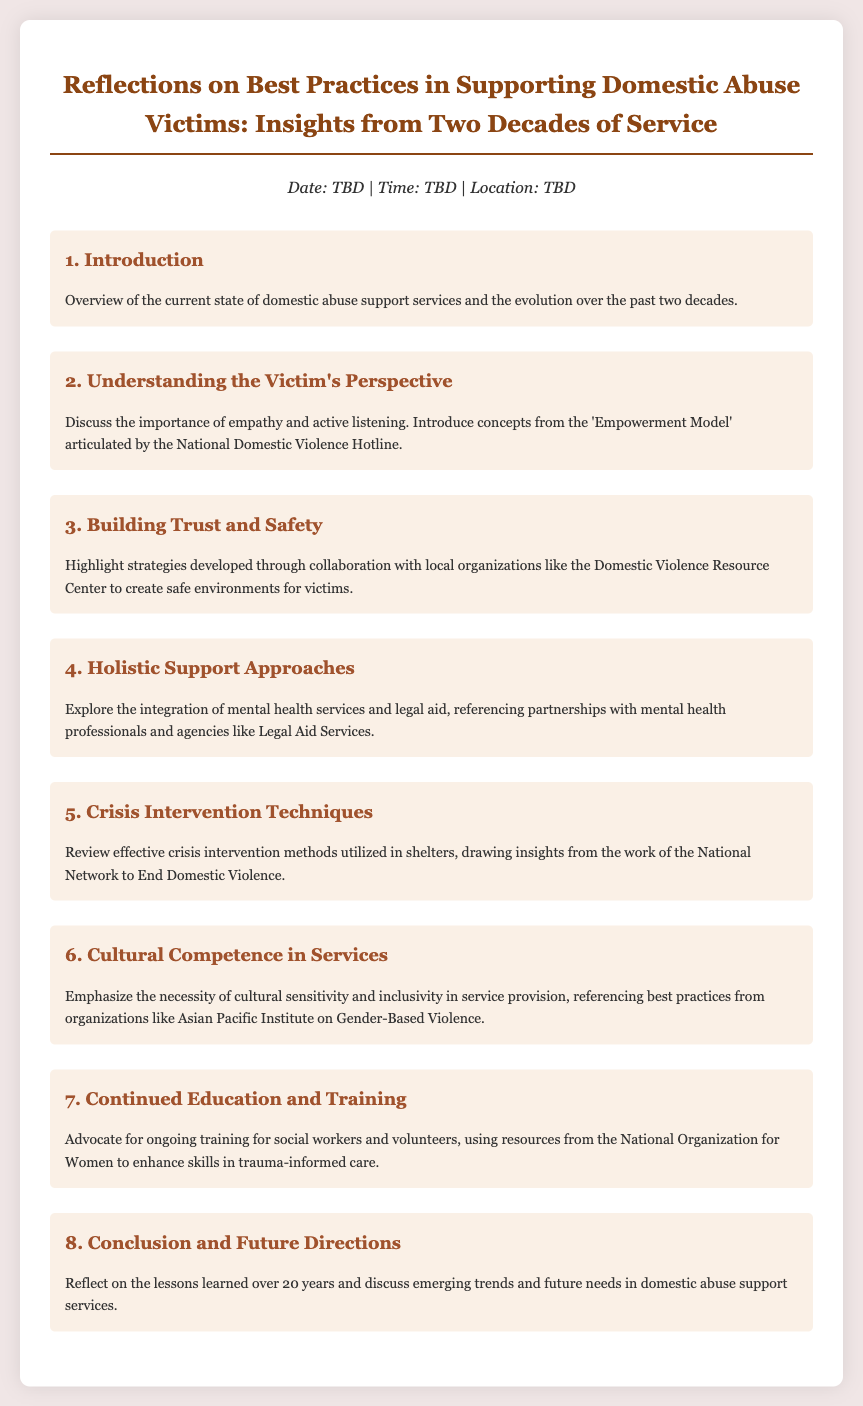What is the title of the document? The title is the main heading of the document, summarizing its central theme and focus area.
Answer: Reflections on Best Practices in Supporting Domestic Abuse Victims: Insights from Two Decades of Service What is the date of the event? The date is mentioned in the agenda details section but is still to be determined (TBD).
Answer: TBD Which model is introduced in the "Understanding the Victim's Perspective" section? The question refers to a specific model mentioned in the document that is important for understanding victims.
Answer: Empowerment Model What are the key areas highlighted in "Crisis Intervention Techniques"? This refers to the focus or prominent themes discussed in the specified section.
Answer: Effective crisis intervention methods What organization is referenced regarding cultural competence? This question asks for the name of an organization mentioned in relation to cultural sensitivity in services.
Answer: Asian Pacific Institute on Gender-Based Violence How many sections are there in the document? This question requires counting the distinct sections or topics outlined in the document.
Answer: Eight What type of approaches are discussed in section 4? This question focuses on the nature of the support that is explored in the designated section.
Answer: Holistic Support Approaches What is emphasized in the "Continued Education and Training" section? This refers to the main focus or advocacy point expressed in the respective section of the agenda.
Answer: Ongoing training What is the primary focus of section 8? This question addresses the purpose or the content that is summed up in the last section of the document.
Answer: Conclusion and Future Directions 